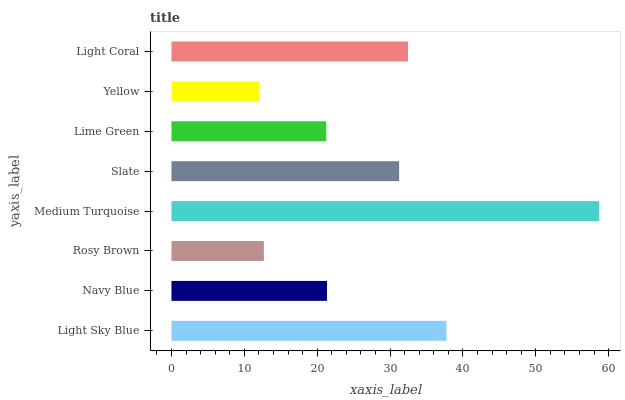Is Yellow the minimum?
Answer yes or no. Yes. Is Medium Turquoise the maximum?
Answer yes or no. Yes. Is Navy Blue the minimum?
Answer yes or no. No. Is Navy Blue the maximum?
Answer yes or no. No. Is Light Sky Blue greater than Navy Blue?
Answer yes or no. Yes. Is Navy Blue less than Light Sky Blue?
Answer yes or no. Yes. Is Navy Blue greater than Light Sky Blue?
Answer yes or no. No. Is Light Sky Blue less than Navy Blue?
Answer yes or no. No. Is Slate the high median?
Answer yes or no. Yes. Is Navy Blue the low median?
Answer yes or no. Yes. Is Yellow the high median?
Answer yes or no. No. Is Slate the low median?
Answer yes or no. No. 